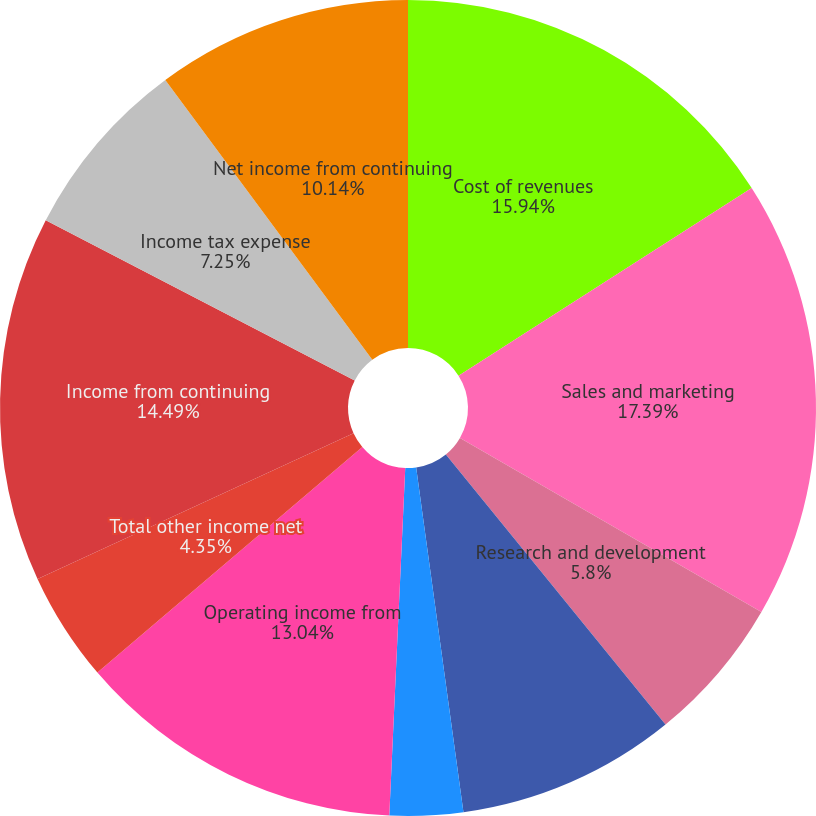Convert chart. <chart><loc_0><loc_0><loc_500><loc_500><pie_chart><fcel>Cost of revenues<fcel>Sales and marketing<fcel>Research and development<fcel>General and administrative<fcel>Restructuring and other<fcel>Operating income from<fcel>Total other income net<fcel>Income from continuing<fcel>Income tax expense<fcel>Net income from continuing<nl><fcel>15.94%<fcel>17.39%<fcel>5.8%<fcel>8.7%<fcel>2.9%<fcel>13.04%<fcel>4.35%<fcel>14.49%<fcel>7.25%<fcel>10.14%<nl></chart> 